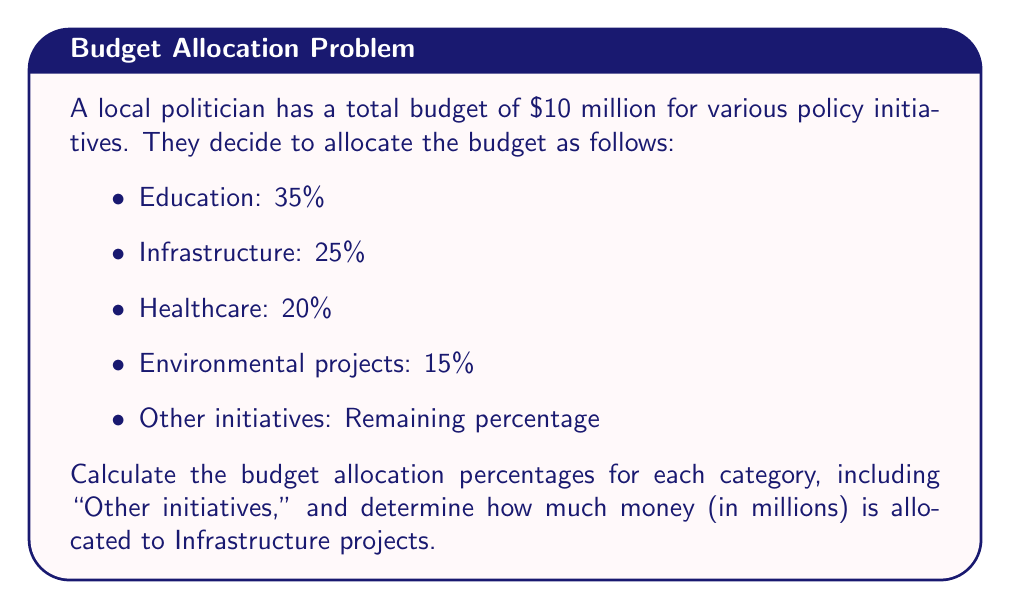Provide a solution to this math problem. Let's approach this step-by-step:

1. First, let's calculate the total percentage allocated to the specified initiatives:
   $35\% + 25\% + 20\% + 15\% = 95\%$

2. The remaining percentage for "Other initiatives" is:
   $100\% - 95\% = 5\%$

3. Now we have the complete percentage breakdown:
   - Education: 35%
   - Infrastructure: 25%
   - Healthcare: 20%
   - Environmental projects: 15%
   - Other initiatives: 5%

4. To calculate the amount allocated to Infrastructure projects:
   - The total budget is $10 million
   - Infrastructure is allocated 25% of the budget
   - Amount = $25\% \times \$10$ million
   - Amount = $0.25 \times \$10$ million = $\$2.5$ million

Therefore, $\$2.5$ million is allocated to Infrastructure projects.
Answer: Education: 35%, Infrastructure: 25%, Healthcare: 20%, Environmental: 15%, Other: 5%; $\$2.5$ million for Infrastructure 